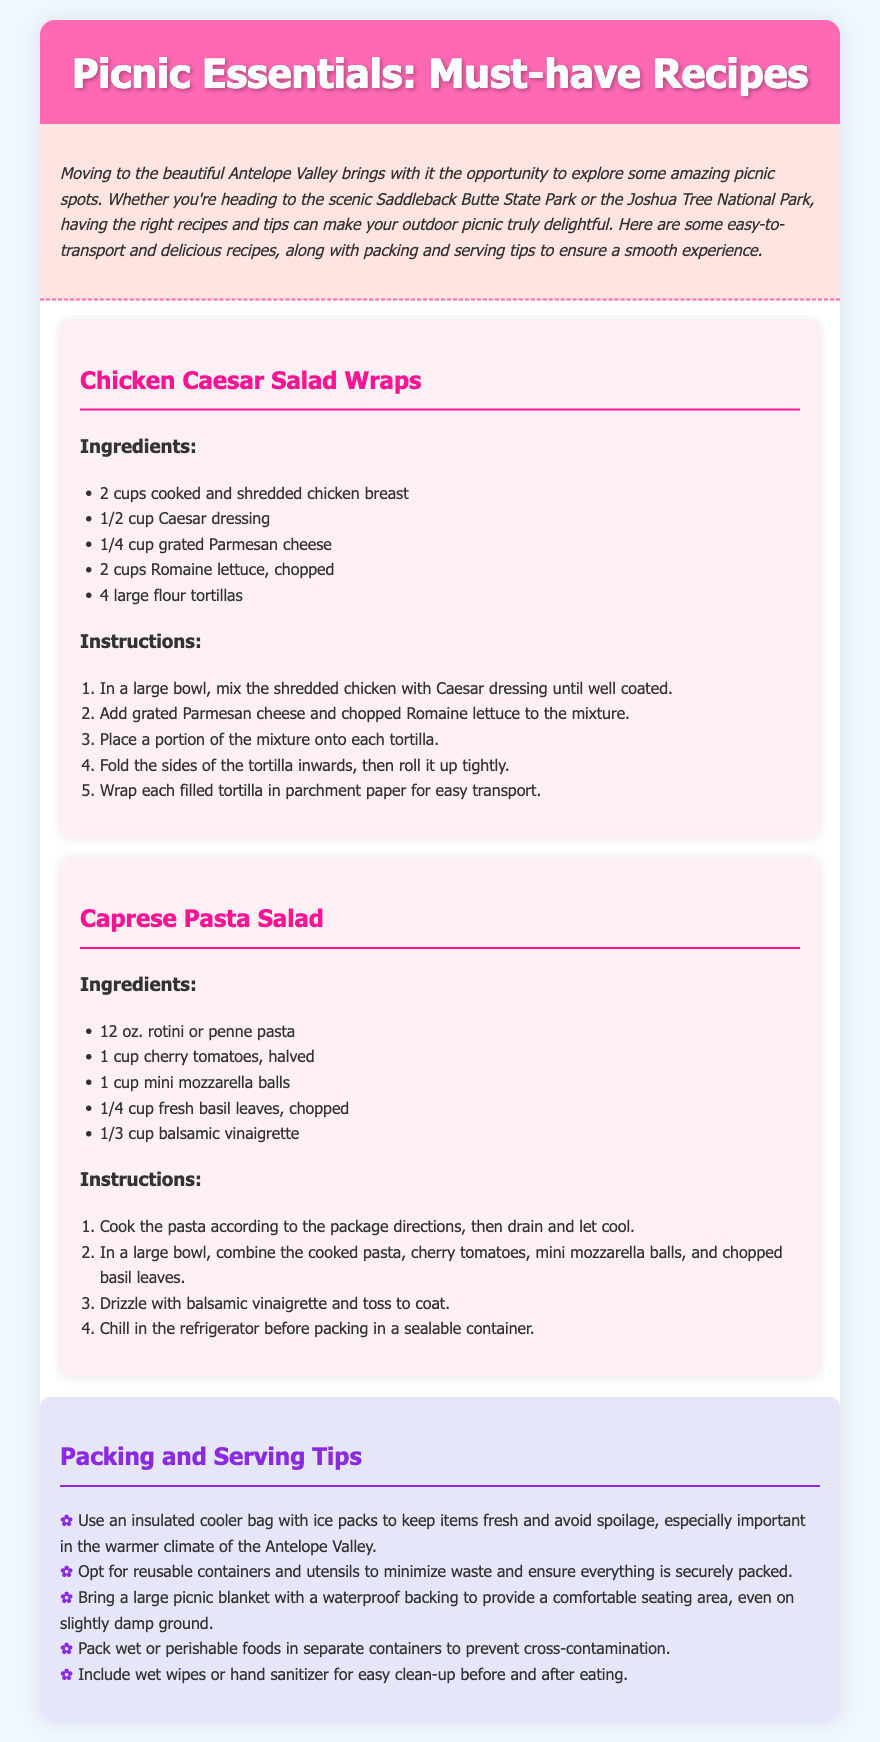What is the title of the document? The title is prominently displayed in the header section of the document.
Answer: Picnic Essentials: Must-have Recipes How many recipes are provided in the document? There are two distinct recipes listed in the document.
Answer: Two What is an ingredient in the Chicken Caesar Salad Wraps? The ingredients list for this recipe includes several items including chicken breast.
Answer: cooked and shredded chicken breast What type of dressing is used in the Caprese Pasta Salad? The ingredients specify the type of dressing used in this recipe.
Answer: balsamic vinaigrette What should you use to keep food fresh during the picnic? The tips provide suggestions for preserving food freshness in warm climates.
Answer: insulated cooler bag Why should you pack wet foods in separate containers? The tips explain the reasoning to prevent food safety issues during transport.
Answer: to prevent cross-contamination What is the recommended seating aid for the picnic? The packing tips detail items to enhance comfort during the picnic.
Answer: picnic blanket with a waterproof backing How many cups of Romaine lettuce are needed for the wraps? The recipe provides a specific quantity for this ingredient.
Answer: 2 cups What is the first step in preparing the Chicken Caesar Salad Wraps? The instructions for the recipe outline the initial steps needed to prepare it.
Answer: Mix the shredded chicken with Caesar dressing until well coated 